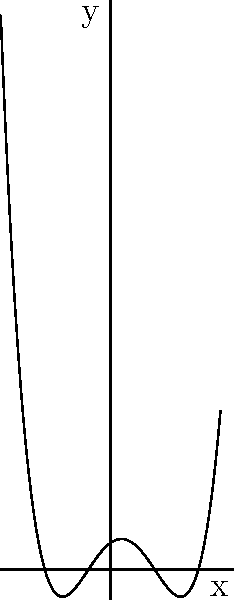As an iOS developer familiar with Swift's powerful type system, consider the polynomial function represented by the graph above. What is the degree of this polynomial? Explain your reasoning based on the graph's behavior and relate it to how Swift's type inference might handle complex mathematical operations. To determine the degree of the polynomial, we need to analyze the graph's behavior:

1. Count the x-intercepts (roots):
   The graph crosses the x-axis 4 times, indicating 4 roots.

2. Observe the end behavior:
   As x approaches positive and negative infinity, y approaches positive infinity.

3. Apply the relationship between roots and degree:
   - The maximum number of roots a polynomial can have is equal to its degree.
   - The end behavior suggests an even degree (both ends going in the same direction).

4. Conclusion:
   The polynomial has 4 roots and even-degree end behavior, so its degree must be 4.

Relating to Swift:
In Swift, type inference would automatically determine the most appropriate numeric type for complex mathematical operations, similar to how we inferred the polynomial's degree from its graphical representation. Just as Swift optimizes for performance and type safety, understanding polynomial degree helps in optimizing algorithms for root-finding or curve-fitting in iOS app development.
Answer: 4 